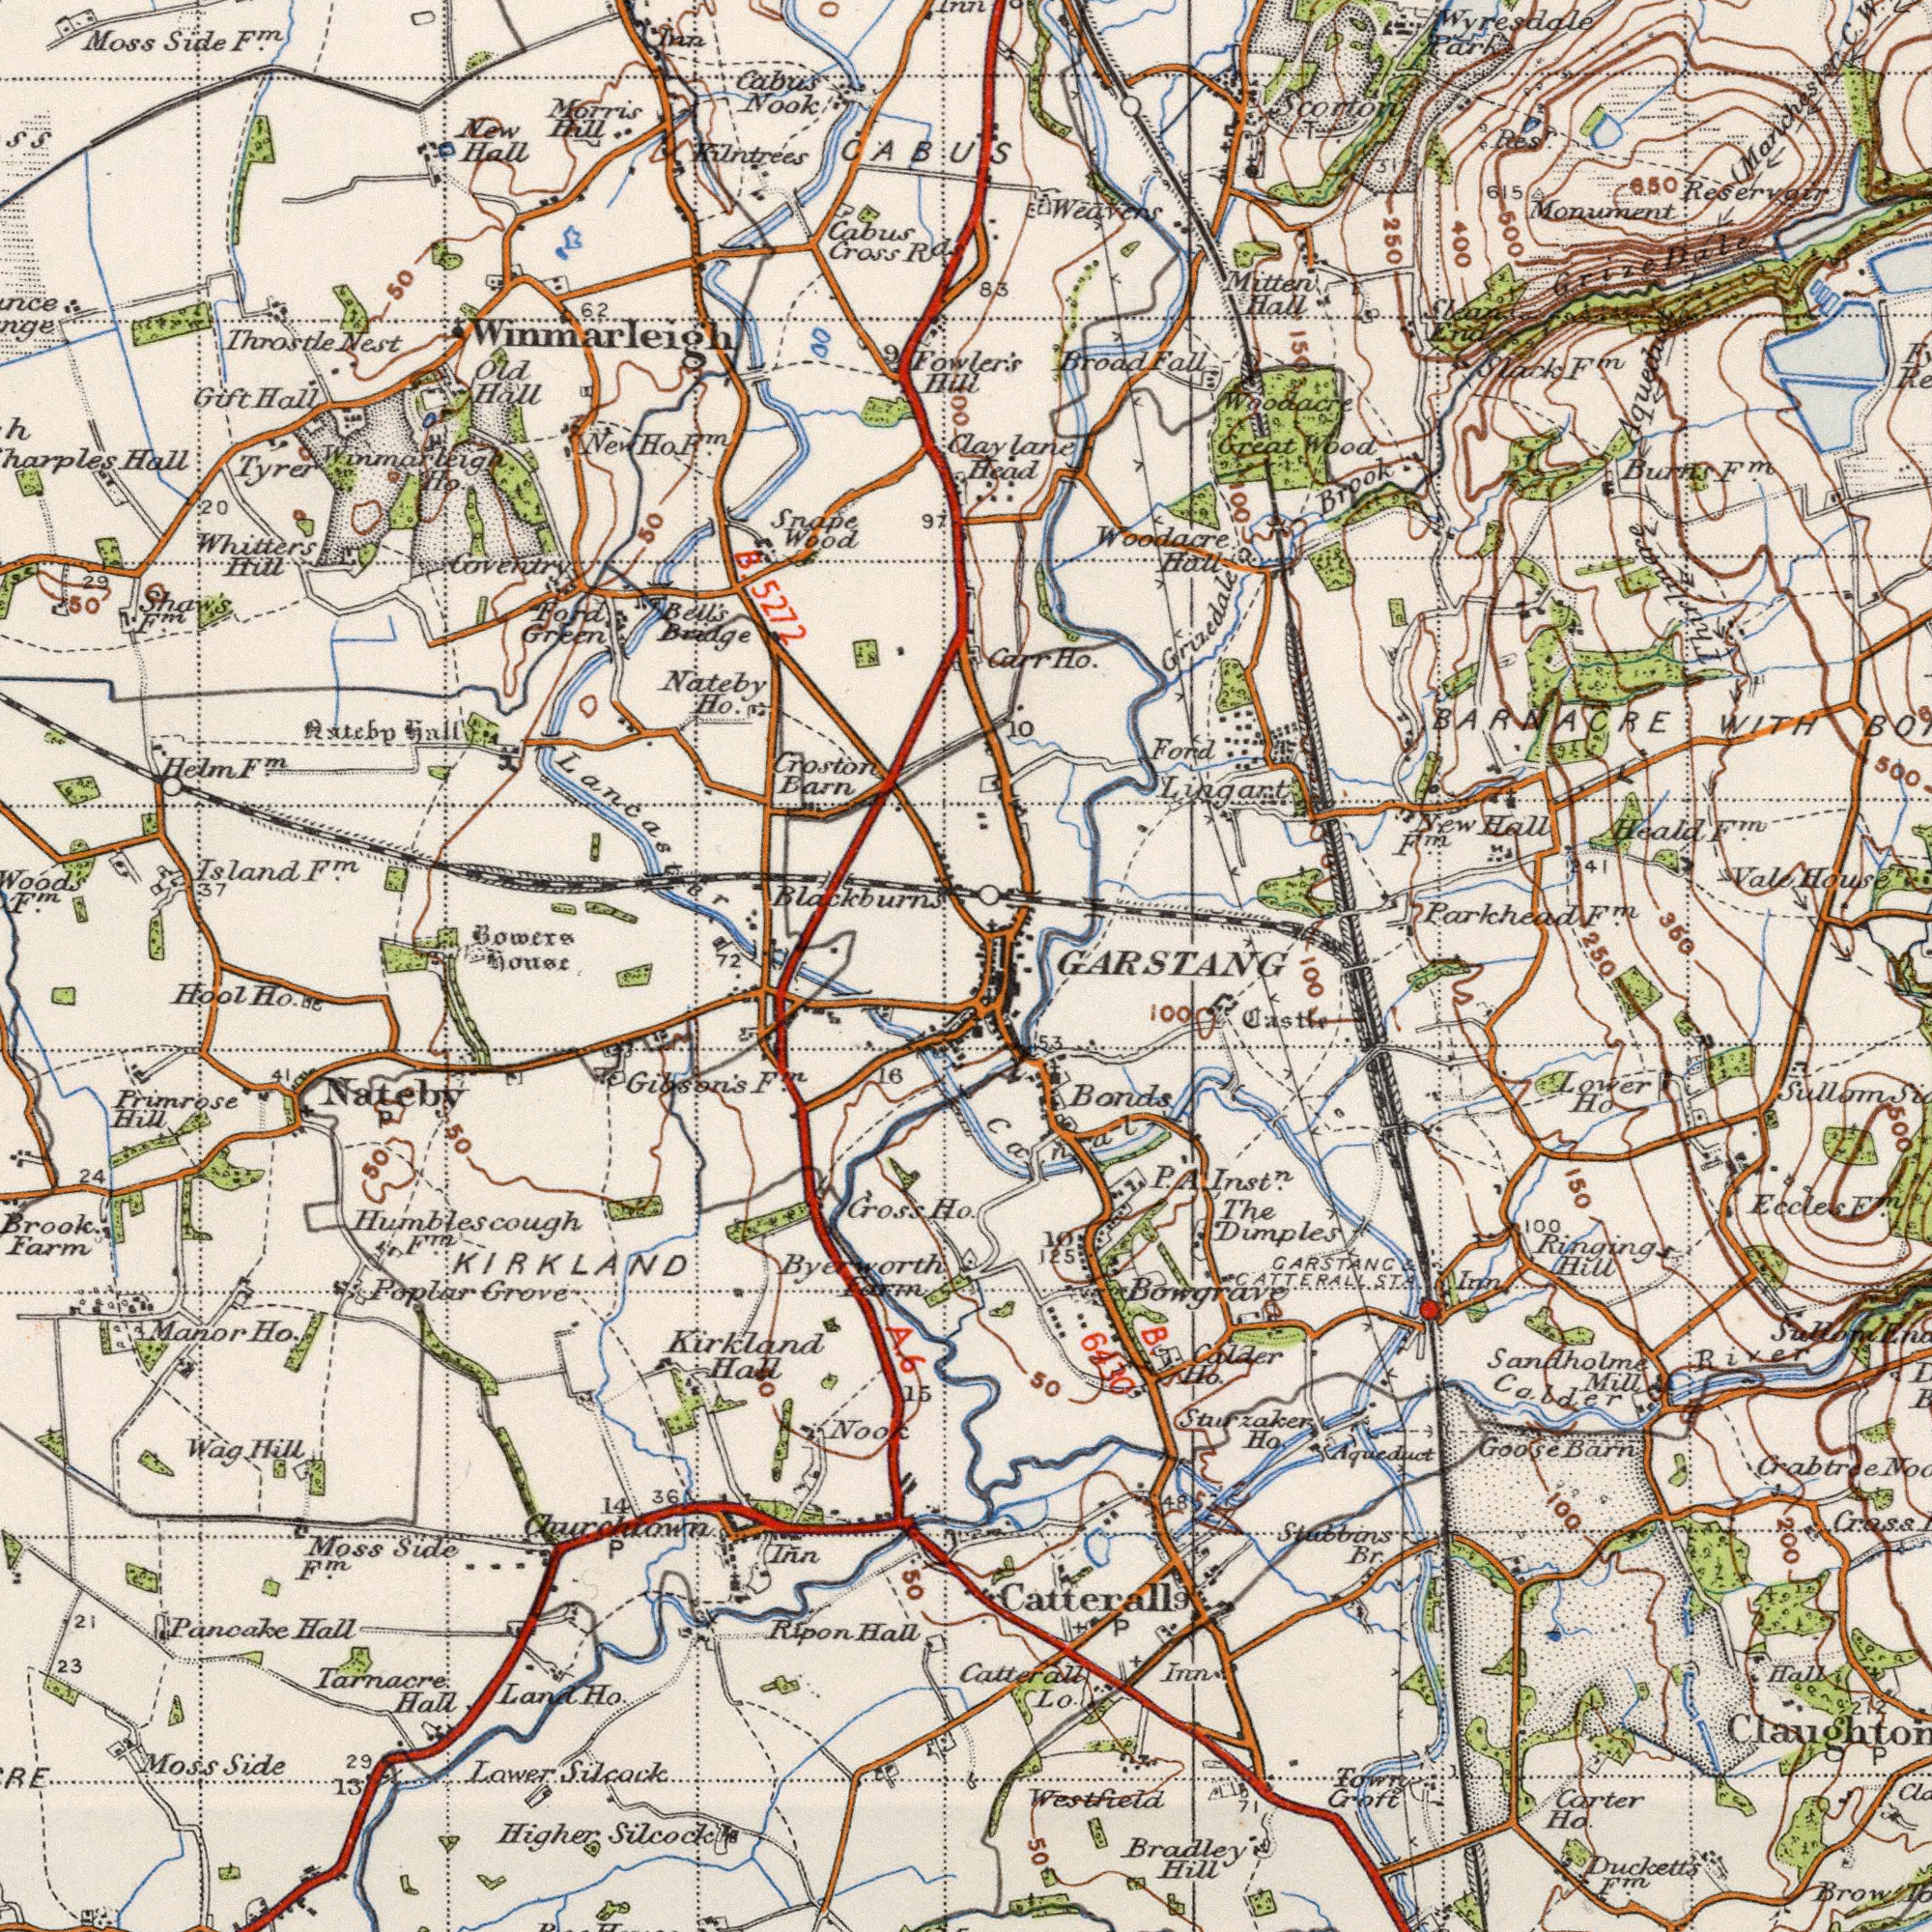What text is shown in the top-left quadrant? Nook Hall Moss Cabus Kilntrees 5272 Winmarleigh Wood's Throstle Hall Cross Hall Rd. Hill Bridge Whitters Bowers Nest ###ateb### Side Coventry Nateby Croston 62 Tyrer 50 Old Hill Helm Gift Hall Bell's Morris Barn Ford New Ho. Wood 50 Inn Lancaster Cabus Island Blackburns F<sup>m</sup>. Snape 50 Hill 97 29 Green B. CABUS F<sup>m</sup>. hall F<sup>m</sup>. Shaw's 20 9 37 F<sup>m</sup>. New Ho. F<sup>m</sup>. F<sup>m</sup>. Ho Winmarleigh Inn 100 What text appears in the top-right area of the image? Fowler's Monument Woodacre Heald Ford Broad WITH Head Hall Mitten Hall Wood 350 Parkhead Grizedale Brook C. BARNACRE 83 31 600 Res<sup>r</sup>. Great Hall Burns Ho. Fall Scorton 10 End Dale Slack (Manchester 500 615 Woodacre Park 400 Lingart Weavers 250 Vale 650 F<sup>m</sup>. Carr Grize Aqueduct Reservoir 150 41 House F<sup>m</sup>. Clean New Wyresdale F<sup>m</sup>. Claylane W. T F<sup>m</sup>. 100 Thirlmore F<sup>m</sup>. What text is visible in the lower-right corner? 250 Sandholme Stabbins Brow Crass 100 Duckett's Inst<sup>n</sup>. Lo. Dimples Cabder Carter Barn Eccles Lower Ho. Bradley Croft Bonds Hill Hall Sullom Br. The Catterall 50 Hill East River 125 Mill 150 Catterall Ho Bowgrave Inn Ho. 50 ST. Town Inn 100 Aqueduct GARSTANC 48 Ringing Goose Sullom P. 53 100 10 P 200 212 CATTERALL P Ho. F<sup>m</sup>. 6430 500 Westfield Sturzaker Crabtree F<sup>m</sup>. canal GARSTANG 100 Calder A 9 B 71 What text is shown in the bottom-left quadrant? KIRKLAND Tarnacre Higher Primrose Brook. Side Pancake Silcock Cross Silcock Gibson's Ripon Hall Hool Poplar Ho. Moss Hall Grove Churchtown Lower Manor Hill Farm Hall Hall Moss Inn 13 Ho. 24 Side Nook 23 14 Kirkland 16 Ho.se Humblescough Hill 15 21 Wag Land Ho. 29 50 Nateby F<sup>m</sup>. F<sup>m</sup>. 50 F<sup>m</sup>. 36 Farm 41 P Byerworth 50 72 House A. 31 6 50 